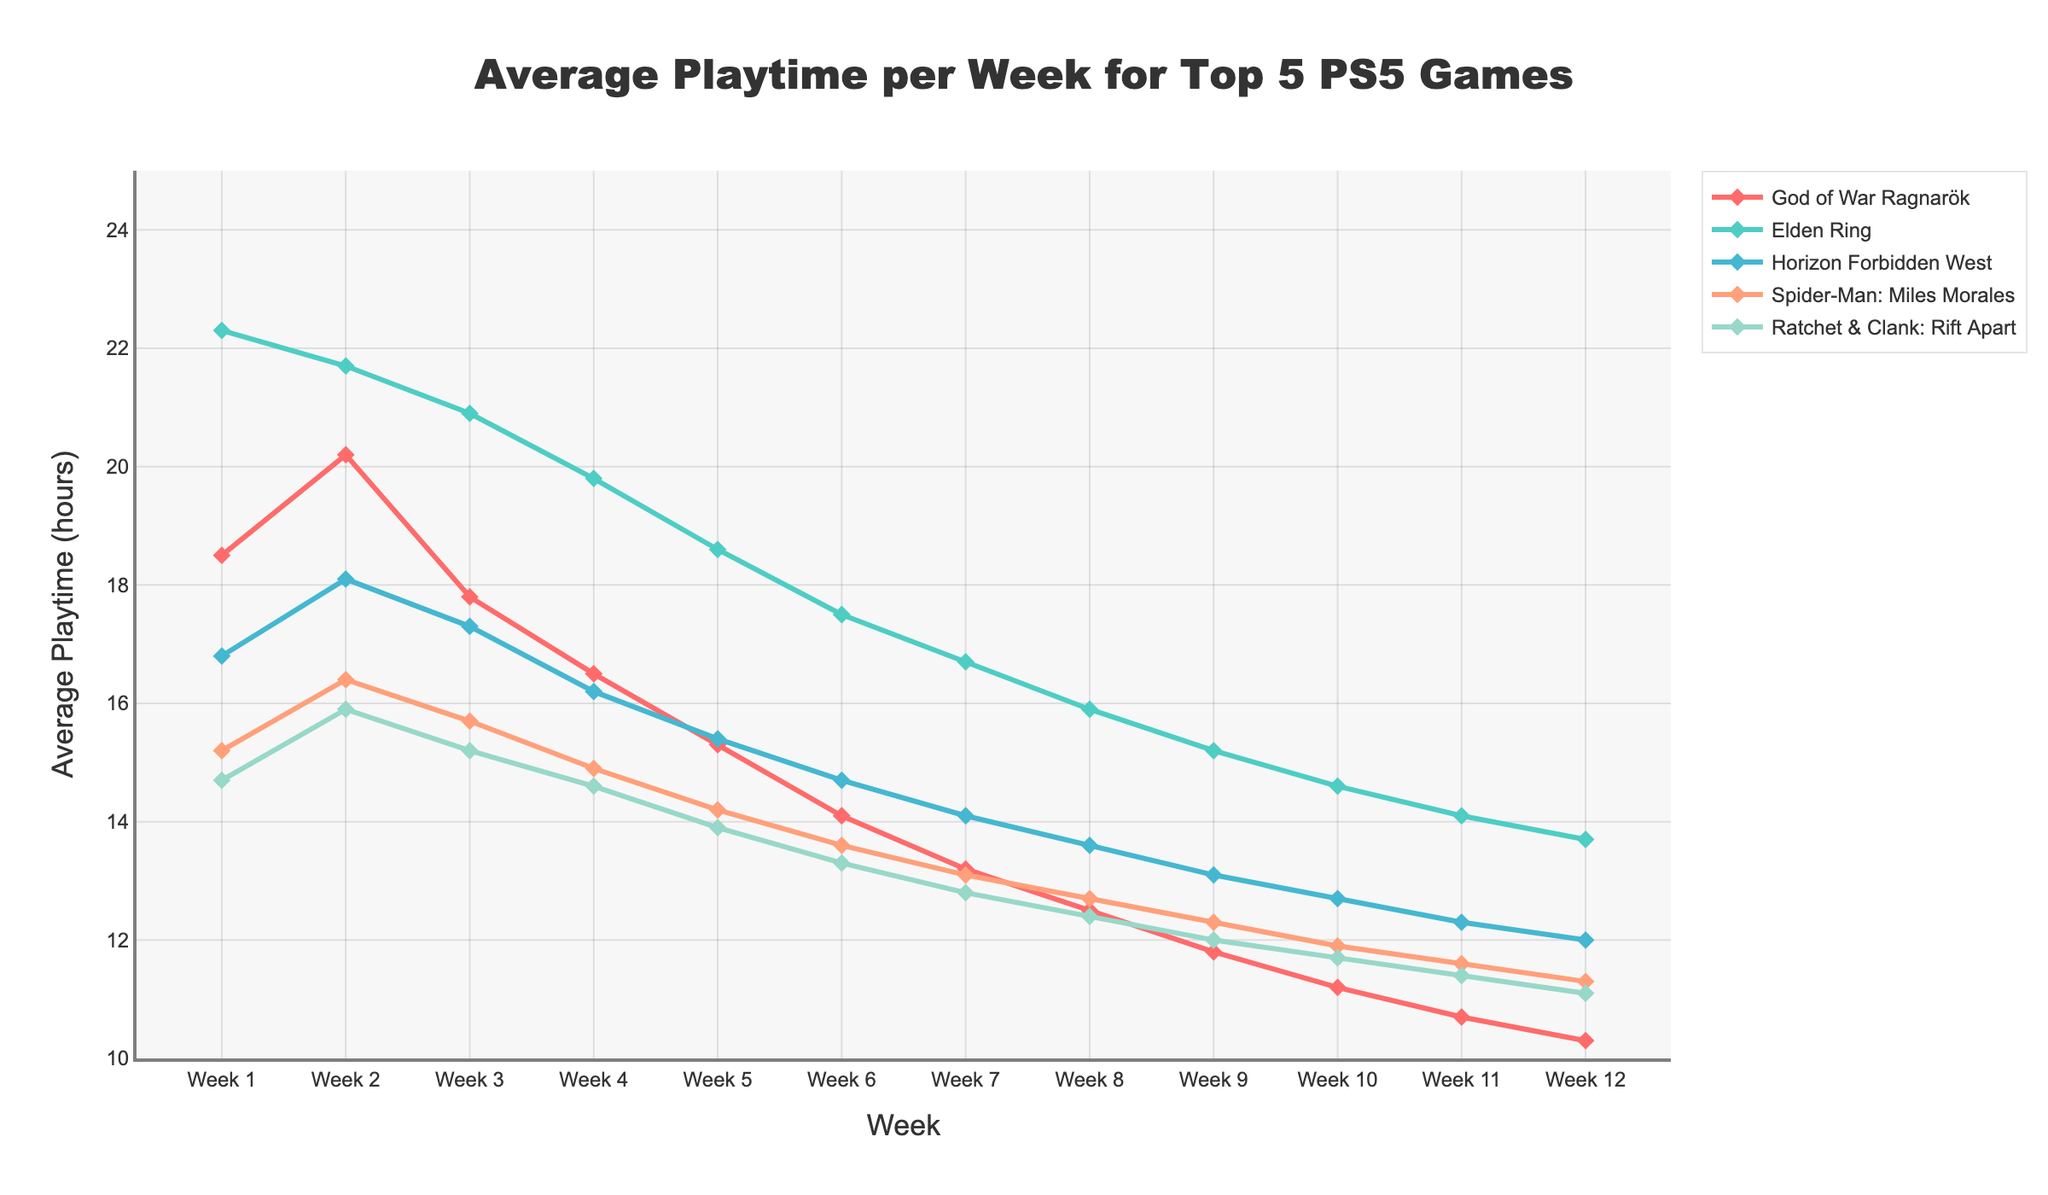what's the average playtime across all games in Week 1? To find the average playtime across all games in Week 1, sum the playtimes for each game and then divide by the number of games: (18.5 + 22.3 + 16.8 + 15.2 + 14.7) / 5 = 87.5 / 5 = 17.5 hours
Answer: 17.5 hours Which game had the highest playtime in Week 6? By inspecting the playtime values in Week 6 for each game, Elden Ring had the highest playtime with 17.5 hours.
Answer: Elden Ring How much did the playtime for God of War Ragnarök decrease from Week 1 to Week 12? Subtract the playtime in Week 12 from the playtime in Week 1 for God of War Ragnarök: 18.5 - 10.3 = 8.2 hours
Answer: 8.2 hours Which game had the steepest decline in playtime over the 12 weeks? By visually comparing the slopes of the decline in playtime, God of War Ragnarök had the steepest decline from 18.5 hours in Week 1 to 10.3 hours in Week 12.
Answer: God of War Ragnarök Was the playtime for Horizon Forbidden West ever higher than the playtime for Spider-Man: Miles Morales in Week 8? Checking Week 8, Horizon Forbidden West has a playtime of 13.6 hours and Spider-Man: Miles Morales has a playtime of 12.7 hours. Therefore, the playtime for Horizon Forbidden West was higher.
Answer: Yes What's the total playtime for Ratchet & Clank: Rift Apart across all 12 weeks? Sum the playtime values for each of the 12 weeks for Ratchet & Clank: Rift Apart: 14.7 + 15.9 + 15.2 + 14.6 + 13.9 + 13.3 + 12.8 + 12.4 + 12.0 + 11.7 + 11.4 + 11.1 = 159 hours
Answer: 159 hours In which week did the playtime of Elden Ring fall below 20 hours for the first time? The first instance where Elden Ring's playtime drops below 20 hours is in Week 4 where it is 19.8 hours.
Answer: Week 4 Compare the playtime trend of Spider-Man: Miles Morales with Horizon Forbidden West over the 12 weeks. Which one declined more steadily? Spider-Man: Miles Morales and Horizon Forbidden West both show a declining trend, but Spider-Man: Miles Morales shows a more consistent and steady decline with smaller differences between weeks whereas Horizon Forbidden West had a less steep and somewhat varied decline.
Answer: Spider-Man: Miles Morales What is the difference in playtime between the highest and lowest recorded playtimes across all games within the 12 weeks? The highest playtime is Elden Ring in Week 1 at 22.3 hours, and the lowest is God of War Ragnarök in Week 12 at 10.3 hours. The difference is 22.3 - 10.3 = 12 hours.
Answer: 12 hours 